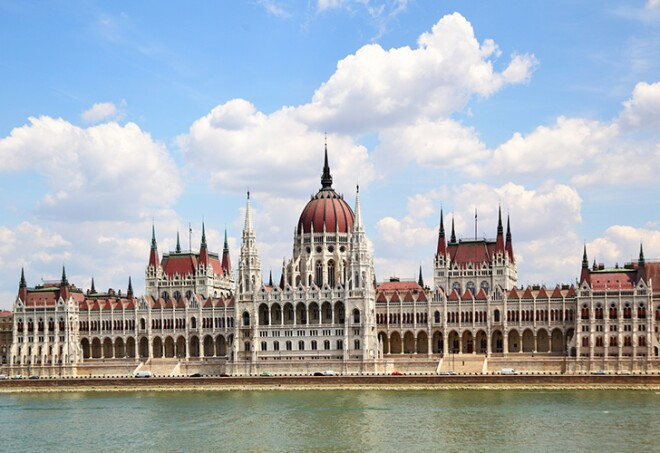What role does the location of the Hungarian Parliament Building play in its historical and cultural significance? The location of the Hungarian Parliament Building on the banks of the Danube River is integral to its historical and cultural significance. Historically, the Danube has been a vital waterway for commerce and transportation, and situating the Parliament along its banks symbolizes Hungary's connection to the rest of Europe. Culturally, the riverfront location makes the building accessible and a central piece of Budapest's cityscape, allowing it to be a daily fixture in the lives of the city's residents and a prominent attraction for visitors. Its reflection in the Danube creates a picturesque scene that reinforces its status as a symbol of national pride. Additionally, the strategic placement provides a constant reminder of the Parliament's governing role to both citizens and lawmakers alike. How does this building compare to other famous parliamentary buildings around the world? The Hungarian Parliament Building stands out for its unique architectural blend and historical intricacies. Compared to the British Houses of Parliament, with its Gothic Revival architecture, the Hungarian Parliament shares this style but diverges with its Renaissance influences and symmetrical design. The US Capitol Building exhibits a more Classical Revival style, featuring a prominent dome and grand staircase, emphasizing American neoclassicism. Meanwhile, the Palace of Westminster in London, like the Hungarian Parliament Building, is situated along a major river, symbolizing both countries' historical connection to their waterways. Each building has its unique charm and significance, but the Hungarian Parliament is particularly noted for its harmonious blend of architectural styles and its significant location in the heart of Europe. Imagine a futuristic scenario where the Hungarian Parliament Building integrates advanced technology. What changes might occur? In a futuristic scenario where the Hungarian Parliament Building integrates advanced technology, numerous changes could transform its operations and visitor experience. Smart building technologies could be embedded to enhance energy efficiency, using AI to monitor and adjust lighting, temperature, and energy usage. Augmented Reality (AR) could provide interactive and immersive tours, allowing visitors to experience historical events as if they were there. Blockchain technology might be used for secure voting and transparent legislative processes. Advanced security systems with biometrics and facial recognition could ensure the safety of the building and its occupants. Additionally, holographic displays and virtual meeting rooms could facilitate international collaborations, making the Hungarian Parliament a hub of cutting-edge governance while preserving the historical essence of its architecture. 